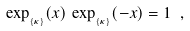<formula> <loc_0><loc_0><loc_500><loc_500>\exp _ { _ { \{ \kappa \} } } ( x ) \, \exp _ { _ { \{ \kappa \} } } ( - x ) = 1 \ ,</formula> 